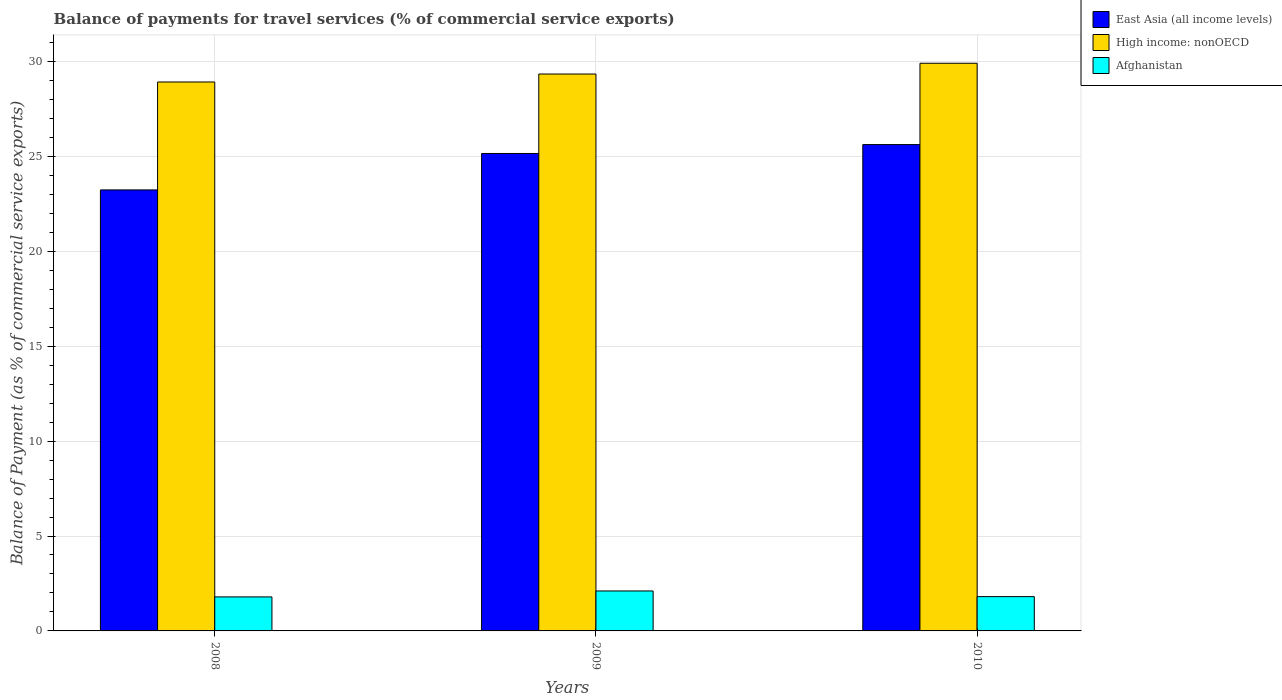Are the number of bars per tick equal to the number of legend labels?
Offer a very short reply. Yes. How many bars are there on the 3rd tick from the left?
Your response must be concise. 3. How many bars are there on the 3rd tick from the right?
Ensure brevity in your answer.  3. In how many cases, is the number of bars for a given year not equal to the number of legend labels?
Provide a succinct answer. 0. What is the balance of payments for travel services in Afghanistan in 2009?
Ensure brevity in your answer.  2.11. Across all years, what is the maximum balance of payments for travel services in East Asia (all income levels)?
Offer a very short reply. 25.62. Across all years, what is the minimum balance of payments for travel services in East Asia (all income levels)?
Make the answer very short. 23.23. In which year was the balance of payments for travel services in East Asia (all income levels) minimum?
Your response must be concise. 2008. What is the total balance of payments for travel services in High income: nonOECD in the graph?
Ensure brevity in your answer.  88.16. What is the difference between the balance of payments for travel services in East Asia (all income levels) in 2008 and that in 2009?
Keep it short and to the point. -1.92. What is the difference between the balance of payments for travel services in High income: nonOECD in 2010 and the balance of payments for travel services in East Asia (all income levels) in 2009?
Keep it short and to the point. 4.75. What is the average balance of payments for travel services in East Asia (all income levels) per year?
Your response must be concise. 24.67. In the year 2008, what is the difference between the balance of payments for travel services in East Asia (all income levels) and balance of payments for travel services in High income: nonOECD?
Give a very brief answer. -5.69. What is the ratio of the balance of payments for travel services in High income: nonOECD in 2009 to that in 2010?
Provide a short and direct response. 0.98. Is the balance of payments for travel services in High income: nonOECD in 2008 less than that in 2009?
Give a very brief answer. Yes. Is the difference between the balance of payments for travel services in East Asia (all income levels) in 2008 and 2010 greater than the difference between the balance of payments for travel services in High income: nonOECD in 2008 and 2010?
Provide a succinct answer. No. What is the difference between the highest and the second highest balance of payments for travel services in High income: nonOECD?
Your answer should be very brief. 0.57. What is the difference between the highest and the lowest balance of payments for travel services in Afghanistan?
Your answer should be compact. 0.31. In how many years, is the balance of payments for travel services in East Asia (all income levels) greater than the average balance of payments for travel services in East Asia (all income levels) taken over all years?
Your answer should be very brief. 2. Is the sum of the balance of payments for travel services in East Asia (all income levels) in 2008 and 2009 greater than the maximum balance of payments for travel services in Afghanistan across all years?
Offer a terse response. Yes. What does the 2nd bar from the left in 2009 represents?
Make the answer very short. High income: nonOECD. What does the 1st bar from the right in 2009 represents?
Offer a terse response. Afghanistan. How many bars are there?
Provide a succinct answer. 9. Are all the bars in the graph horizontal?
Your response must be concise. No. How many years are there in the graph?
Offer a very short reply. 3. Does the graph contain grids?
Your answer should be compact. Yes. Where does the legend appear in the graph?
Your answer should be very brief. Top right. How many legend labels are there?
Offer a terse response. 3. How are the legend labels stacked?
Keep it short and to the point. Vertical. What is the title of the graph?
Offer a very short reply. Balance of payments for travel services (% of commercial service exports). What is the label or title of the Y-axis?
Ensure brevity in your answer.  Balance of Payment (as % of commercial service exports). What is the Balance of Payment (as % of commercial service exports) of East Asia (all income levels) in 2008?
Give a very brief answer. 23.23. What is the Balance of Payment (as % of commercial service exports) of High income: nonOECD in 2008?
Your answer should be very brief. 28.92. What is the Balance of Payment (as % of commercial service exports) in Afghanistan in 2008?
Make the answer very short. 1.79. What is the Balance of Payment (as % of commercial service exports) of East Asia (all income levels) in 2009?
Keep it short and to the point. 25.15. What is the Balance of Payment (as % of commercial service exports) of High income: nonOECD in 2009?
Offer a terse response. 29.34. What is the Balance of Payment (as % of commercial service exports) in Afghanistan in 2009?
Offer a terse response. 2.11. What is the Balance of Payment (as % of commercial service exports) in East Asia (all income levels) in 2010?
Give a very brief answer. 25.62. What is the Balance of Payment (as % of commercial service exports) of High income: nonOECD in 2010?
Your answer should be very brief. 29.91. What is the Balance of Payment (as % of commercial service exports) in Afghanistan in 2010?
Your response must be concise. 1.81. Across all years, what is the maximum Balance of Payment (as % of commercial service exports) of East Asia (all income levels)?
Your answer should be compact. 25.62. Across all years, what is the maximum Balance of Payment (as % of commercial service exports) in High income: nonOECD?
Offer a terse response. 29.91. Across all years, what is the maximum Balance of Payment (as % of commercial service exports) of Afghanistan?
Your answer should be compact. 2.11. Across all years, what is the minimum Balance of Payment (as % of commercial service exports) of East Asia (all income levels)?
Ensure brevity in your answer.  23.23. Across all years, what is the minimum Balance of Payment (as % of commercial service exports) in High income: nonOECD?
Keep it short and to the point. 28.92. Across all years, what is the minimum Balance of Payment (as % of commercial service exports) of Afghanistan?
Ensure brevity in your answer.  1.79. What is the total Balance of Payment (as % of commercial service exports) of East Asia (all income levels) in the graph?
Your answer should be very brief. 74.01. What is the total Balance of Payment (as % of commercial service exports) of High income: nonOECD in the graph?
Offer a terse response. 88.16. What is the total Balance of Payment (as % of commercial service exports) in Afghanistan in the graph?
Ensure brevity in your answer.  5.7. What is the difference between the Balance of Payment (as % of commercial service exports) in East Asia (all income levels) in 2008 and that in 2009?
Your response must be concise. -1.92. What is the difference between the Balance of Payment (as % of commercial service exports) of High income: nonOECD in 2008 and that in 2009?
Your answer should be compact. -0.42. What is the difference between the Balance of Payment (as % of commercial service exports) of Afghanistan in 2008 and that in 2009?
Your answer should be compact. -0.31. What is the difference between the Balance of Payment (as % of commercial service exports) in East Asia (all income levels) in 2008 and that in 2010?
Your response must be concise. -2.39. What is the difference between the Balance of Payment (as % of commercial service exports) of High income: nonOECD in 2008 and that in 2010?
Keep it short and to the point. -0.99. What is the difference between the Balance of Payment (as % of commercial service exports) in Afghanistan in 2008 and that in 2010?
Provide a short and direct response. -0.02. What is the difference between the Balance of Payment (as % of commercial service exports) of East Asia (all income levels) in 2009 and that in 2010?
Provide a short and direct response. -0.47. What is the difference between the Balance of Payment (as % of commercial service exports) of High income: nonOECD in 2009 and that in 2010?
Offer a terse response. -0.57. What is the difference between the Balance of Payment (as % of commercial service exports) in Afghanistan in 2009 and that in 2010?
Keep it short and to the point. 0.3. What is the difference between the Balance of Payment (as % of commercial service exports) of East Asia (all income levels) in 2008 and the Balance of Payment (as % of commercial service exports) of High income: nonOECD in 2009?
Provide a short and direct response. -6.11. What is the difference between the Balance of Payment (as % of commercial service exports) of East Asia (all income levels) in 2008 and the Balance of Payment (as % of commercial service exports) of Afghanistan in 2009?
Offer a very short reply. 21.13. What is the difference between the Balance of Payment (as % of commercial service exports) in High income: nonOECD in 2008 and the Balance of Payment (as % of commercial service exports) in Afghanistan in 2009?
Offer a terse response. 26.81. What is the difference between the Balance of Payment (as % of commercial service exports) of East Asia (all income levels) in 2008 and the Balance of Payment (as % of commercial service exports) of High income: nonOECD in 2010?
Offer a very short reply. -6.67. What is the difference between the Balance of Payment (as % of commercial service exports) in East Asia (all income levels) in 2008 and the Balance of Payment (as % of commercial service exports) in Afghanistan in 2010?
Keep it short and to the point. 21.43. What is the difference between the Balance of Payment (as % of commercial service exports) of High income: nonOECD in 2008 and the Balance of Payment (as % of commercial service exports) of Afghanistan in 2010?
Ensure brevity in your answer.  27.11. What is the difference between the Balance of Payment (as % of commercial service exports) of East Asia (all income levels) in 2009 and the Balance of Payment (as % of commercial service exports) of High income: nonOECD in 2010?
Offer a terse response. -4.75. What is the difference between the Balance of Payment (as % of commercial service exports) of East Asia (all income levels) in 2009 and the Balance of Payment (as % of commercial service exports) of Afghanistan in 2010?
Give a very brief answer. 23.35. What is the difference between the Balance of Payment (as % of commercial service exports) in High income: nonOECD in 2009 and the Balance of Payment (as % of commercial service exports) in Afghanistan in 2010?
Provide a succinct answer. 27.53. What is the average Balance of Payment (as % of commercial service exports) in East Asia (all income levels) per year?
Offer a terse response. 24.67. What is the average Balance of Payment (as % of commercial service exports) in High income: nonOECD per year?
Provide a short and direct response. 29.39. What is the average Balance of Payment (as % of commercial service exports) in Afghanistan per year?
Your answer should be compact. 1.9. In the year 2008, what is the difference between the Balance of Payment (as % of commercial service exports) in East Asia (all income levels) and Balance of Payment (as % of commercial service exports) in High income: nonOECD?
Provide a short and direct response. -5.69. In the year 2008, what is the difference between the Balance of Payment (as % of commercial service exports) in East Asia (all income levels) and Balance of Payment (as % of commercial service exports) in Afghanistan?
Offer a very short reply. 21.44. In the year 2008, what is the difference between the Balance of Payment (as % of commercial service exports) in High income: nonOECD and Balance of Payment (as % of commercial service exports) in Afghanistan?
Keep it short and to the point. 27.13. In the year 2009, what is the difference between the Balance of Payment (as % of commercial service exports) of East Asia (all income levels) and Balance of Payment (as % of commercial service exports) of High income: nonOECD?
Keep it short and to the point. -4.19. In the year 2009, what is the difference between the Balance of Payment (as % of commercial service exports) of East Asia (all income levels) and Balance of Payment (as % of commercial service exports) of Afghanistan?
Ensure brevity in your answer.  23.05. In the year 2009, what is the difference between the Balance of Payment (as % of commercial service exports) in High income: nonOECD and Balance of Payment (as % of commercial service exports) in Afghanistan?
Give a very brief answer. 27.23. In the year 2010, what is the difference between the Balance of Payment (as % of commercial service exports) in East Asia (all income levels) and Balance of Payment (as % of commercial service exports) in High income: nonOECD?
Offer a terse response. -4.28. In the year 2010, what is the difference between the Balance of Payment (as % of commercial service exports) of East Asia (all income levels) and Balance of Payment (as % of commercial service exports) of Afghanistan?
Provide a short and direct response. 23.81. In the year 2010, what is the difference between the Balance of Payment (as % of commercial service exports) of High income: nonOECD and Balance of Payment (as % of commercial service exports) of Afghanistan?
Your response must be concise. 28.1. What is the ratio of the Balance of Payment (as % of commercial service exports) in East Asia (all income levels) in 2008 to that in 2009?
Make the answer very short. 0.92. What is the ratio of the Balance of Payment (as % of commercial service exports) of High income: nonOECD in 2008 to that in 2009?
Offer a very short reply. 0.99. What is the ratio of the Balance of Payment (as % of commercial service exports) of Afghanistan in 2008 to that in 2009?
Give a very brief answer. 0.85. What is the ratio of the Balance of Payment (as % of commercial service exports) of East Asia (all income levels) in 2008 to that in 2010?
Offer a terse response. 0.91. What is the ratio of the Balance of Payment (as % of commercial service exports) of High income: nonOECD in 2008 to that in 2010?
Offer a terse response. 0.97. What is the ratio of the Balance of Payment (as % of commercial service exports) in Afghanistan in 2008 to that in 2010?
Give a very brief answer. 0.99. What is the ratio of the Balance of Payment (as % of commercial service exports) in East Asia (all income levels) in 2009 to that in 2010?
Offer a terse response. 0.98. What is the ratio of the Balance of Payment (as % of commercial service exports) in Afghanistan in 2009 to that in 2010?
Your answer should be very brief. 1.16. What is the difference between the highest and the second highest Balance of Payment (as % of commercial service exports) in East Asia (all income levels)?
Provide a succinct answer. 0.47. What is the difference between the highest and the second highest Balance of Payment (as % of commercial service exports) in High income: nonOECD?
Your answer should be compact. 0.57. What is the difference between the highest and the second highest Balance of Payment (as % of commercial service exports) in Afghanistan?
Give a very brief answer. 0.3. What is the difference between the highest and the lowest Balance of Payment (as % of commercial service exports) in East Asia (all income levels)?
Provide a succinct answer. 2.39. What is the difference between the highest and the lowest Balance of Payment (as % of commercial service exports) of High income: nonOECD?
Keep it short and to the point. 0.99. What is the difference between the highest and the lowest Balance of Payment (as % of commercial service exports) of Afghanistan?
Keep it short and to the point. 0.31. 